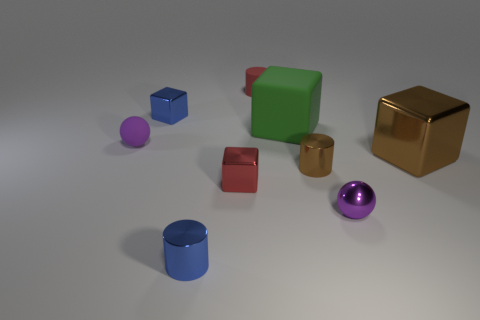Subtract all big matte cubes. How many cubes are left? 3 Add 4 small red shiny objects. How many small red shiny objects exist? 5 Subtract all blue cubes. How many cubes are left? 3 Subtract 0 green cylinders. How many objects are left? 9 Subtract all cubes. How many objects are left? 5 Subtract 1 balls. How many balls are left? 1 Subtract all purple blocks. Subtract all purple balls. How many blocks are left? 4 Subtract all yellow spheres. How many red cubes are left? 1 Subtract all tiny gray matte cubes. Subtract all metallic blocks. How many objects are left? 6 Add 6 brown objects. How many brown objects are left? 8 